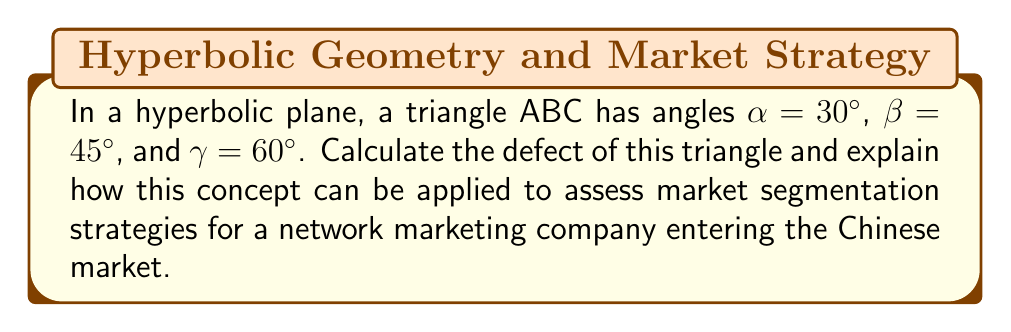Solve this math problem. 1) In Euclidean geometry, the sum of angles in a triangle is always 180°. However, in hyperbolic geometry, this sum is always less than 180°.

2) The difference between 180° and the sum of angles in a hyperbolic triangle is called the defect. Let's denote the defect as $\delta$.

3) The formula for the defect is:

   $$\delta = 180° - (\alpha + \beta + \gamma)$$

4) Substituting the given angles:

   $$\delta = 180° - (30° + 45° + 60°)$$
   $$\delta = 180° - 135° = 45°$$

5) In hyperbolic geometry, the area of a triangle is directly proportional to its defect. The larger the defect, the larger the area.

6) Applying this to market segmentation:
   - Each angle could represent a market segment (e.g., age groups, income levels, geographic regions in China).
   - The defect (45°) represents the untapped market potential or the degree of differentiation between segments.
   - A larger defect suggests more distinct, less overlapping market segments, indicating a need for highly tailored marketing strategies for each segment.
   - A smaller defect would suggest more homogeneous segments, potentially allowing for more unified marketing approaches.

7) For a network marketing company entering the Chinese market, this 45° defect suggests significant differences between the identified market segments, necessitating distinct strategies for each to maximize market penetration and growth.
Answer: 45° 